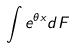<formula> <loc_0><loc_0><loc_500><loc_500>\int e ^ { \theta x } d F</formula> 